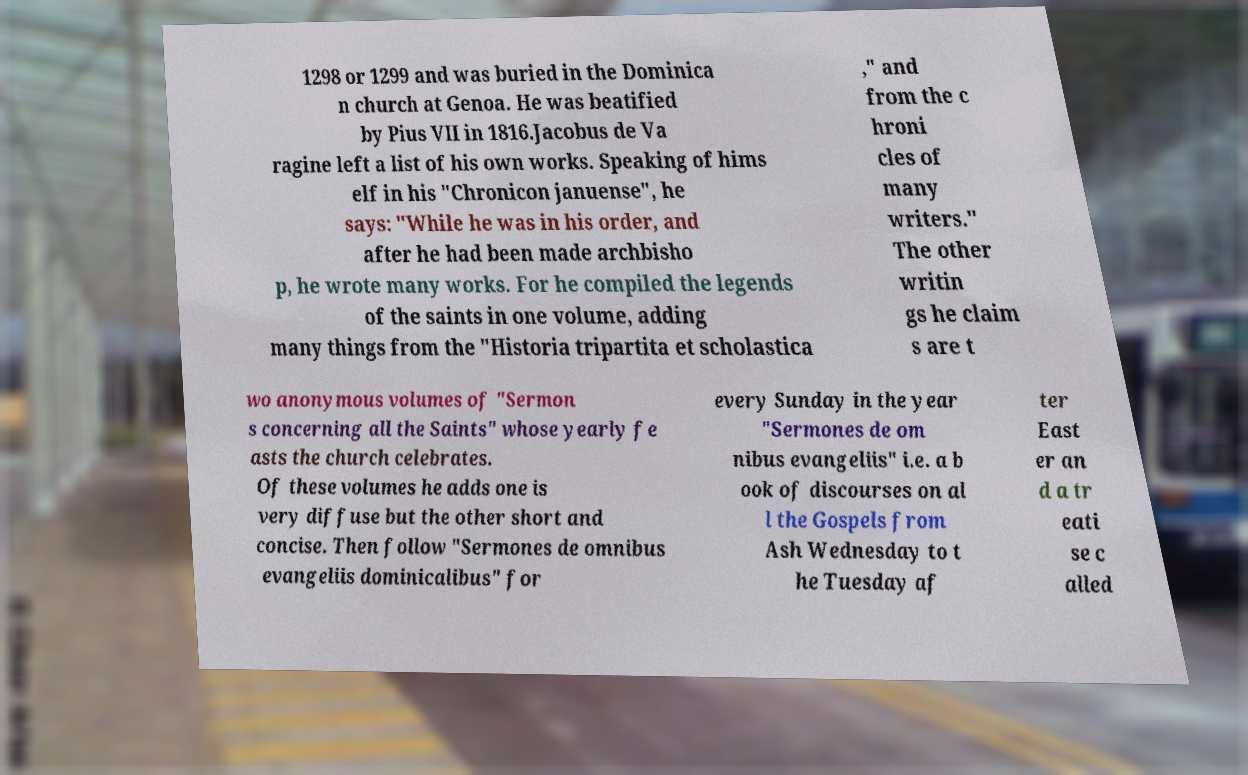I need the written content from this picture converted into text. Can you do that? 1298 or 1299 and was buried in the Dominica n church at Genoa. He was beatified by Pius VII in 1816.Jacobus de Va ragine left a list of his own works. Speaking of hims elf in his "Chronicon januense", he says: "While he was in his order, and after he had been made archbisho p, he wrote many works. For he compiled the legends of the saints in one volume, adding many things from the "Historia tripartita et scholastica ," and from the c hroni cles of many writers." The other writin gs he claim s are t wo anonymous volumes of "Sermon s concerning all the Saints" whose yearly fe asts the church celebrates. Of these volumes he adds one is very diffuse but the other short and concise. Then follow "Sermones de omnibus evangeliis dominicalibus" for every Sunday in the year "Sermones de om nibus evangeliis" i.e. a b ook of discourses on al l the Gospels from Ash Wednesday to t he Tuesday af ter East er an d a tr eati se c alled 